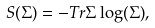<formula> <loc_0><loc_0><loc_500><loc_500>S ( \Sigma ) = - T r { \Sigma \log ( \Sigma ) } ,</formula> 